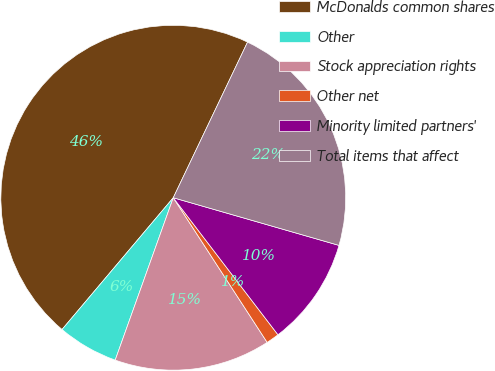Convert chart. <chart><loc_0><loc_0><loc_500><loc_500><pie_chart><fcel>McDonalds common shares<fcel>Other<fcel>Stock appreciation rights<fcel>Other net<fcel>Minority limited partners'<fcel>Total items that affect<nl><fcel>45.93%<fcel>5.69%<fcel>14.63%<fcel>1.22%<fcel>10.16%<fcel>22.37%<nl></chart> 